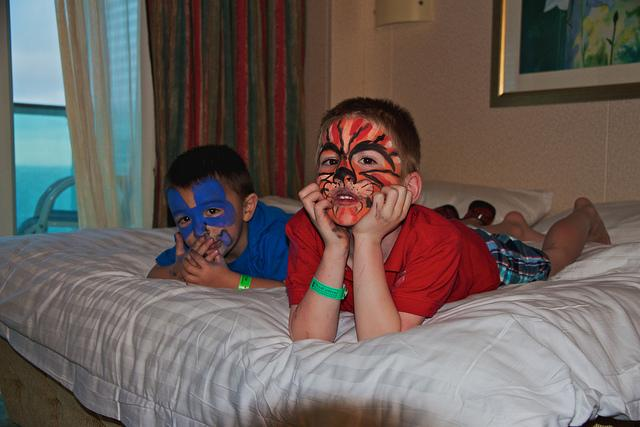Where are these children located?

Choices:
A) hotel
B) hospital
C) classroom
D) playground hotel 